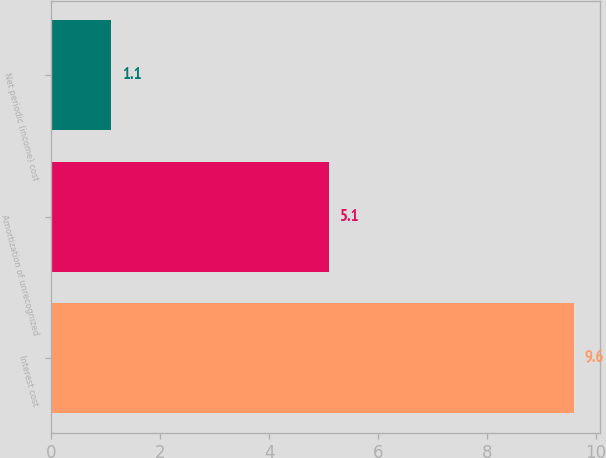Convert chart. <chart><loc_0><loc_0><loc_500><loc_500><bar_chart><fcel>Interest cost<fcel>Amortization of unrecognized<fcel>Net periodic (income) cost<nl><fcel>9.6<fcel>5.1<fcel>1.1<nl></chart> 